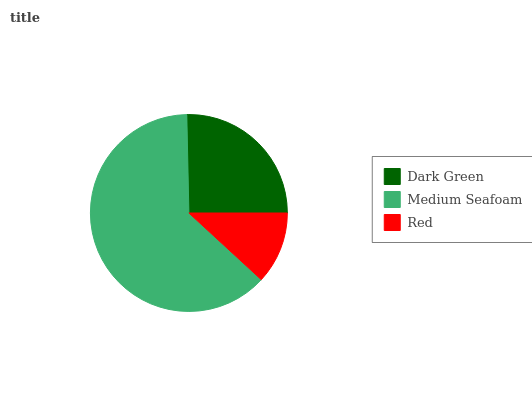Is Red the minimum?
Answer yes or no. Yes. Is Medium Seafoam the maximum?
Answer yes or no. Yes. Is Medium Seafoam the minimum?
Answer yes or no. No. Is Red the maximum?
Answer yes or no. No. Is Medium Seafoam greater than Red?
Answer yes or no. Yes. Is Red less than Medium Seafoam?
Answer yes or no. Yes. Is Red greater than Medium Seafoam?
Answer yes or no. No. Is Medium Seafoam less than Red?
Answer yes or no. No. Is Dark Green the high median?
Answer yes or no. Yes. Is Dark Green the low median?
Answer yes or no. Yes. Is Medium Seafoam the high median?
Answer yes or no. No. Is Medium Seafoam the low median?
Answer yes or no. No. 